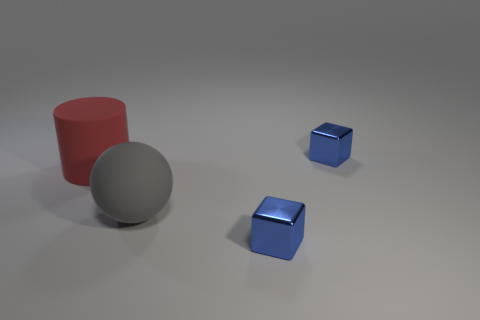Is there any other thing that has the same shape as the big red object?
Provide a short and direct response. No. There is a cube that is in front of the big cylinder; is its size the same as the rubber thing that is in front of the cylinder?
Provide a short and direct response. No. Are the red thing and the blue cube that is in front of the big gray rubber ball made of the same material?
Provide a short and direct response. No. Is the number of red things that are to the right of the red cylinder greater than the number of rubber spheres that are behind the ball?
Ensure brevity in your answer.  No. What is the color of the metallic object that is behind the small blue metal object that is in front of the big sphere?
Offer a very short reply. Blue. How many cylinders are big gray objects or tiny objects?
Keep it short and to the point. 0. What number of objects are in front of the big gray sphere and on the left side of the big gray ball?
Keep it short and to the point. 0. The matte cylinder behind the large gray object is what color?
Keep it short and to the point. Red. The sphere that is made of the same material as the cylinder is what size?
Your answer should be compact. Large. What number of small things are left of the small blue shiny thing that is behind the red thing?
Provide a succinct answer. 1. 